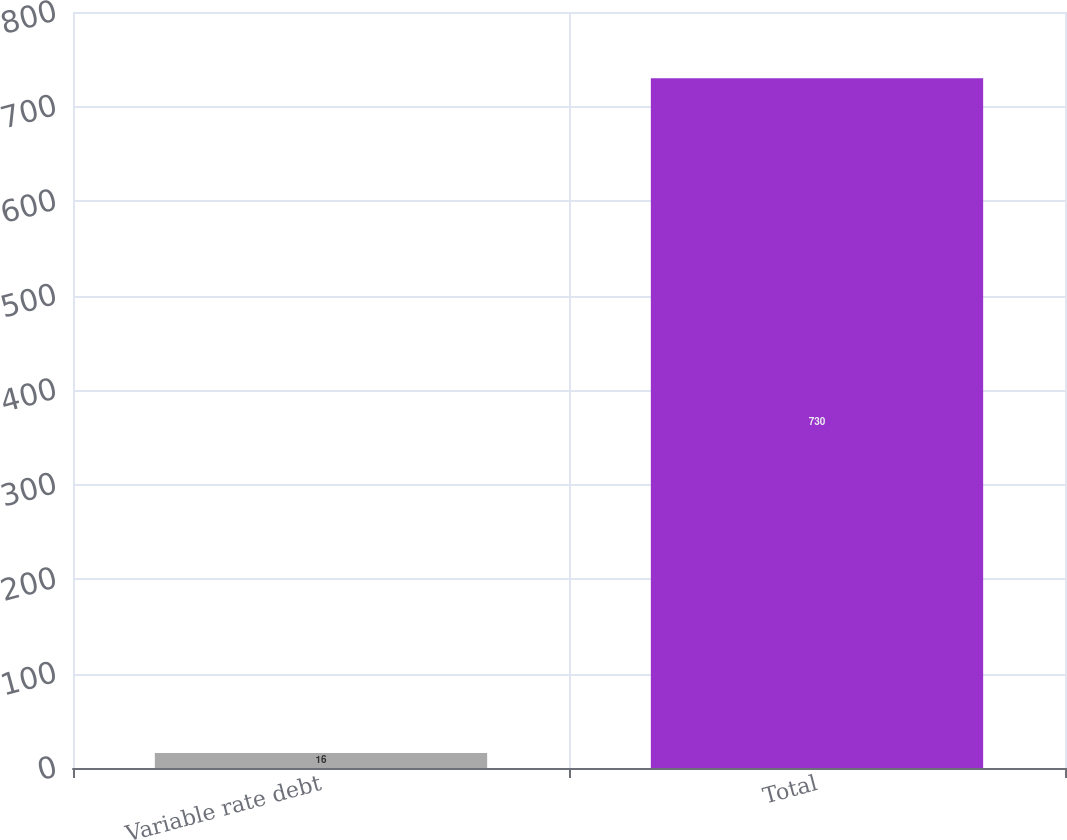Convert chart. <chart><loc_0><loc_0><loc_500><loc_500><bar_chart><fcel>Variable rate debt<fcel>Total<nl><fcel>16<fcel>730<nl></chart> 